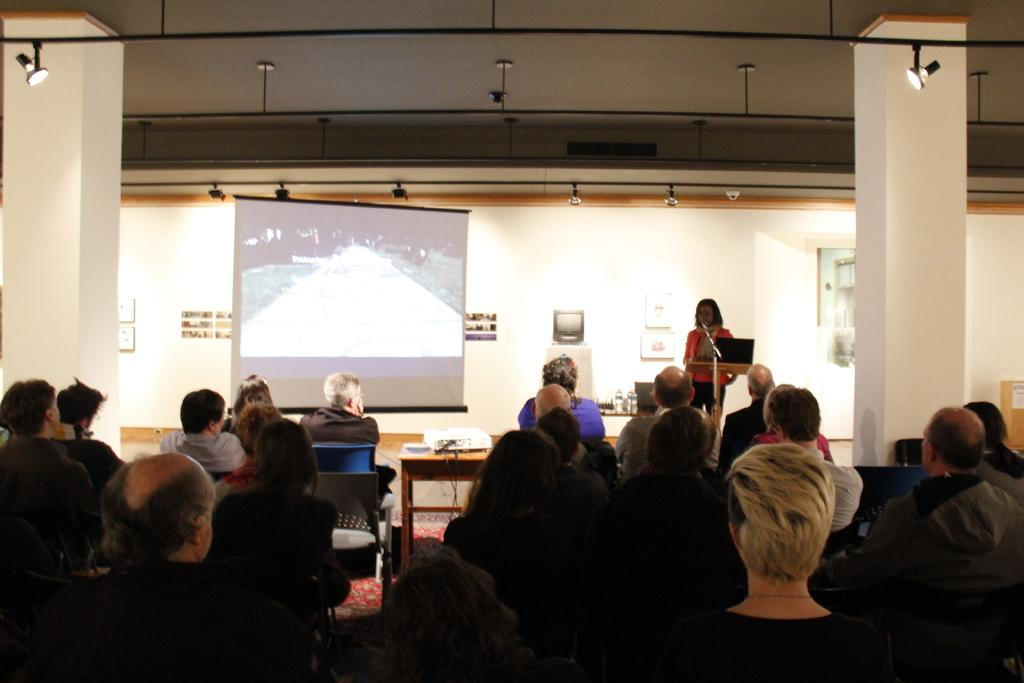How many people are in the image? There is a group of people in the image. What are the people doing in the image? The people are sitting on chairs. Where are the chairs located in relation to the table? The chairs are in front of a table. What is the purpose of the projector screen in the image? The projector screen is likely used for presentations or displaying visuals. What is the role of the woman standing in the image? The woman standing in the image might be a presenter or facilitator. What type of silver clam is being used as a microphone in the image? There is no silver clam or microphone present in the image. 